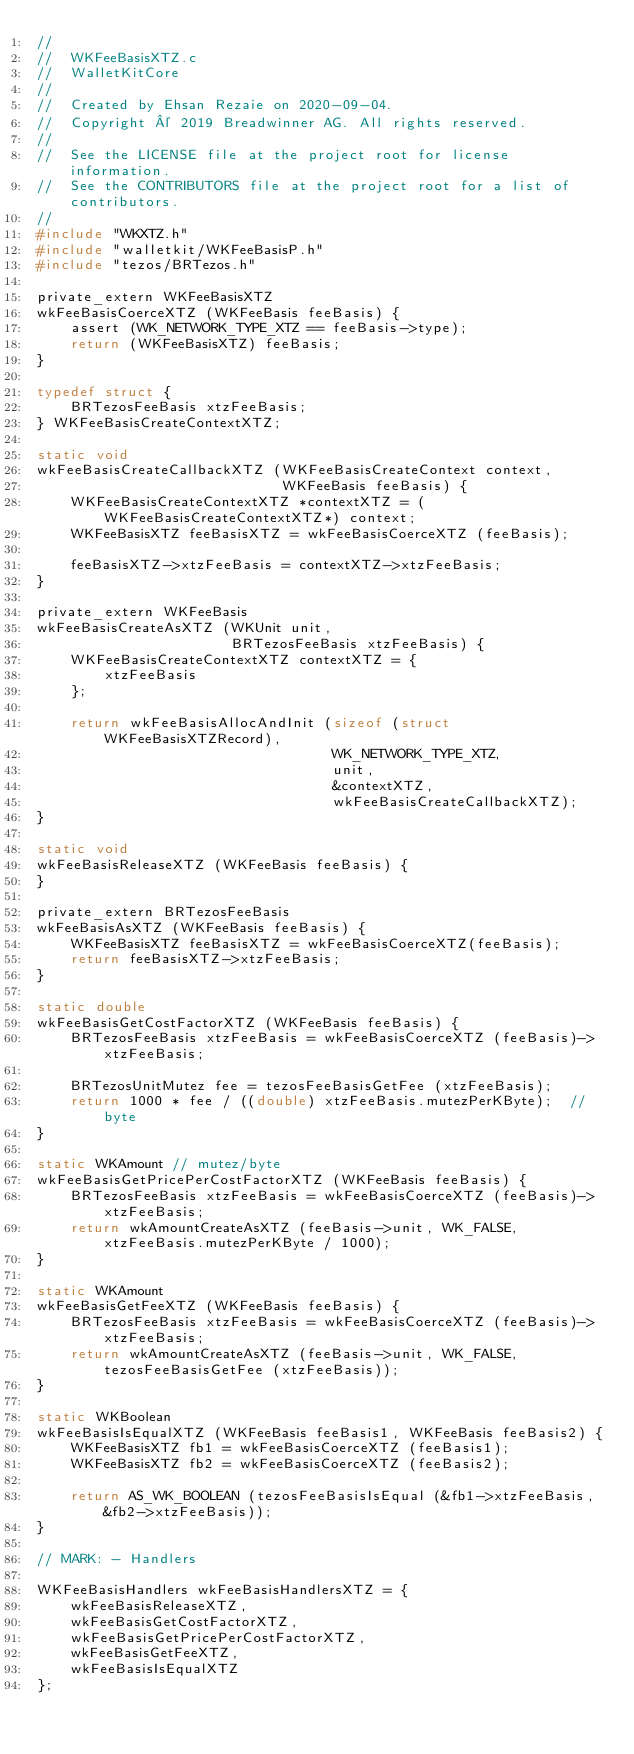Convert code to text. <code><loc_0><loc_0><loc_500><loc_500><_C_>//
//  WKFeeBasisXTZ.c
//  WalletKitCore
//
//  Created by Ehsan Rezaie on 2020-09-04.
//  Copyright © 2019 Breadwinner AG. All rights reserved.
//
//  See the LICENSE file at the project root for license information.
//  See the CONTRIBUTORS file at the project root for a list of contributors.
//
#include "WKXTZ.h"
#include "walletkit/WKFeeBasisP.h"
#include "tezos/BRTezos.h"

private_extern WKFeeBasisXTZ
wkFeeBasisCoerceXTZ (WKFeeBasis feeBasis) {
    assert (WK_NETWORK_TYPE_XTZ == feeBasis->type);
    return (WKFeeBasisXTZ) feeBasis;
}

typedef struct {
    BRTezosFeeBasis xtzFeeBasis;
} WKFeeBasisCreateContextXTZ;

static void
wkFeeBasisCreateCallbackXTZ (WKFeeBasisCreateContext context,
                             WKFeeBasis feeBasis) {
    WKFeeBasisCreateContextXTZ *contextXTZ = (WKFeeBasisCreateContextXTZ*) context;
    WKFeeBasisXTZ feeBasisXTZ = wkFeeBasisCoerceXTZ (feeBasis);
    
    feeBasisXTZ->xtzFeeBasis = contextXTZ->xtzFeeBasis;
}

private_extern WKFeeBasis
wkFeeBasisCreateAsXTZ (WKUnit unit,
                       BRTezosFeeBasis xtzFeeBasis) {
    WKFeeBasisCreateContextXTZ contextXTZ = {
        xtzFeeBasis
    };
    
    return wkFeeBasisAllocAndInit (sizeof (struct WKFeeBasisXTZRecord),
                                   WK_NETWORK_TYPE_XTZ,
                                   unit,
                                   &contextXTZ,
                                   wkFeeBasisCreateCallbackXTZ);
}

static void
wkFeeBasisReleaseXTZ (WKFeeBasis feeBasis) {
}

private_extern BRTezosFeeBasis
wkFeeBasisAsXTZ (WKFeeBasis feeBasis) {
    WKFeeBasisXTZ feeBasisXTZ = wkFeeBasisCoerceXTZ(feeBasis);
    return feeBasisXTZ->xtzFeeBasis;
}

static double
wkFeeBasisGetCostFactorXTZ (WKFeeBasis feeBasis) {
    BRTezosFeeBasis xtzFeeBasis = wkFeeBasisCoerceXTZ (feeBasis)->xtzFeeBasis;

    BRTezosUnitMutez fee = tezosFeeBasisGetFee (xtzFeeBasis);
    return 1000 * fee / ((double) xtzFeeBasis.mutezPerKByte);  // byte
}

static WKAmount // mutez/byte
wkFeeBasisGetPricePerCostFactorXTZ (WKFeeBasis feeBasis) {
    BRTezosFeeBasis xtzFeeBasis = wkFeeBasisCoerceXTZ (feeBasis)->xtzFeeBasis;
    return wkAmountCreateAsXTZ (feeBasis->unit, WK_FALSE, xtzFeeBasis.mutezPerKByte / 1000);
}

static WKAmount
wkFeeBasisGetFeeXTZ (WKFeeBasis feeBasis) {
    BRTezosFeeBasis xtzFeeBasis = wkFeeBasisCoerceXTZ (feeBasis)->xtzFeeBasis;
    return wkAmountCreateAsXTZ (feeBasis->unit, WK_FALSE, tezosFeeBasisGetFee (xtzFeeBasis));
}

static WKBoolean
wkFeeBasisIsEqualXTZ (WKFeeBasis feeBasis1, WKFeeBasis feeBasis2) {
    WKFeeBasisXTZ fb1 = wkFeeBasisCoerceXTZ (feeBasis1);
    WKFeeBasisXTZ fb2 = wkFeeBasisCoerceXTZ (feeBasis2);
    
    return AS_WK_BOOLEAN (tezosFeeBasisIsEqual (&fb1->xtzFeeBasis, &fb2->xtzFeeBasis));
}

// MARK: - Handlers

WKFeeBasisHandlers wkFeeBasisHandlersXTZ = {
    wkFeeBasisReleaseXTZ,
    wkFeeBasisGetCostFactorXTZ,
    wkFeeBasisGetPricePerCostFactorXTZ,
    wkFeeBasisGetFeeXTZ,
    wkFeeBasisIsEqualXTZ
};

</code> 